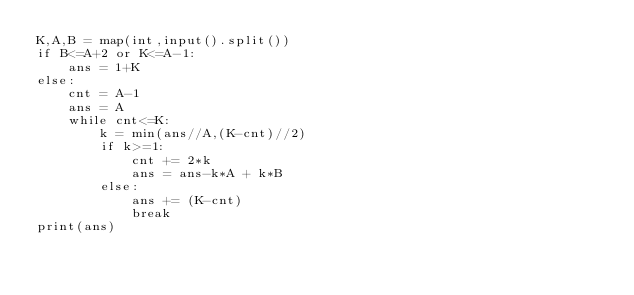Convert code to text. <code><loc_0><loc_0><loc_500><loc_500><_Python_>K,A,B = map(int,input().split())
if B<=A+2 or K<=A-1:
    ans = 1+K
else:
    cnt = A-1
    ans = A
    while cnt<=K:
        k = min(ans//A,(K-cnt)//2)
        if k>=1:
            cnt += 2*k
            ans = ans-k*A + k*B
        else:
            ans += (K-cnt)
            break
print(ans)</code> 